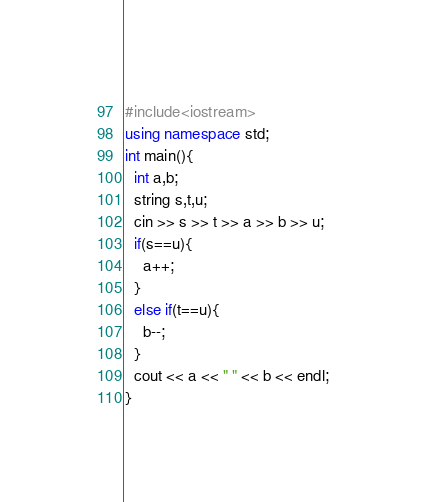Convert code to text. <code><loc_0><loc_0><loc_500><loc_500><_C++_>#include<iostream>
using namespace std;
int main(){
  int a,b;
  string s,t,u;
  cin >> s >> t >> a >> b >> u;
  if(s==u){
    a++;
  }
  else if(t==u){
    b--;
  }
  cout << a << " " << b << endl;
}</code> 